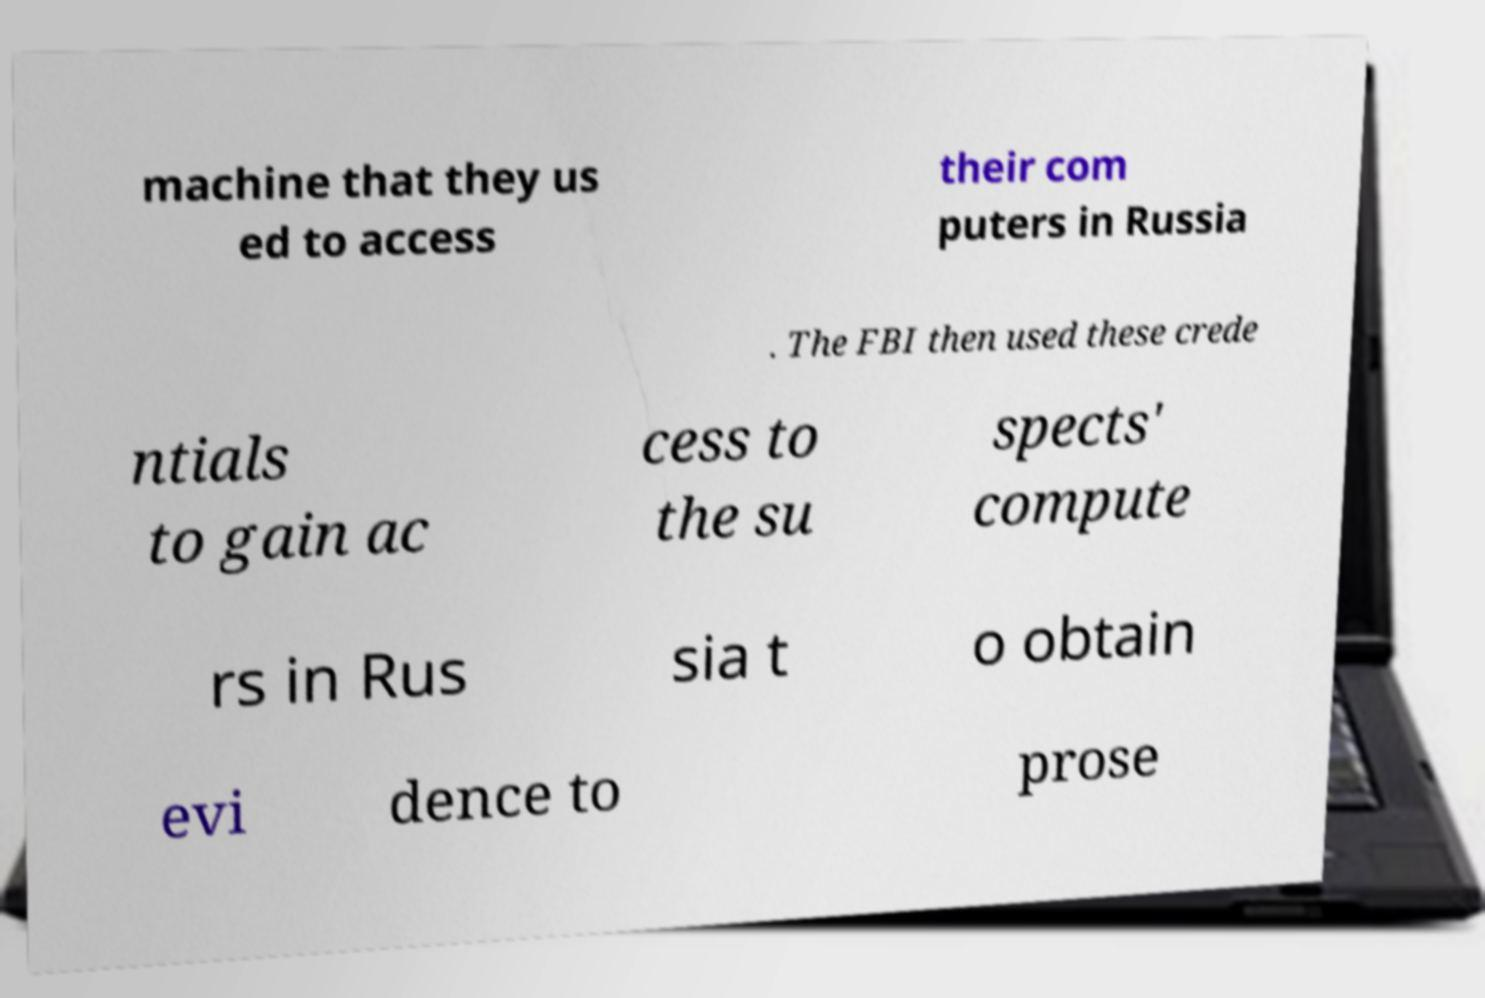What messages or text are displayed in this image? I need them in a readable, typed format. machine that they us ed to access their com puters in Russia . The FBI then used these crede ntials to gain ac cess to the su spects' compute rs in Rus sia t o obtain evi dence to prose 